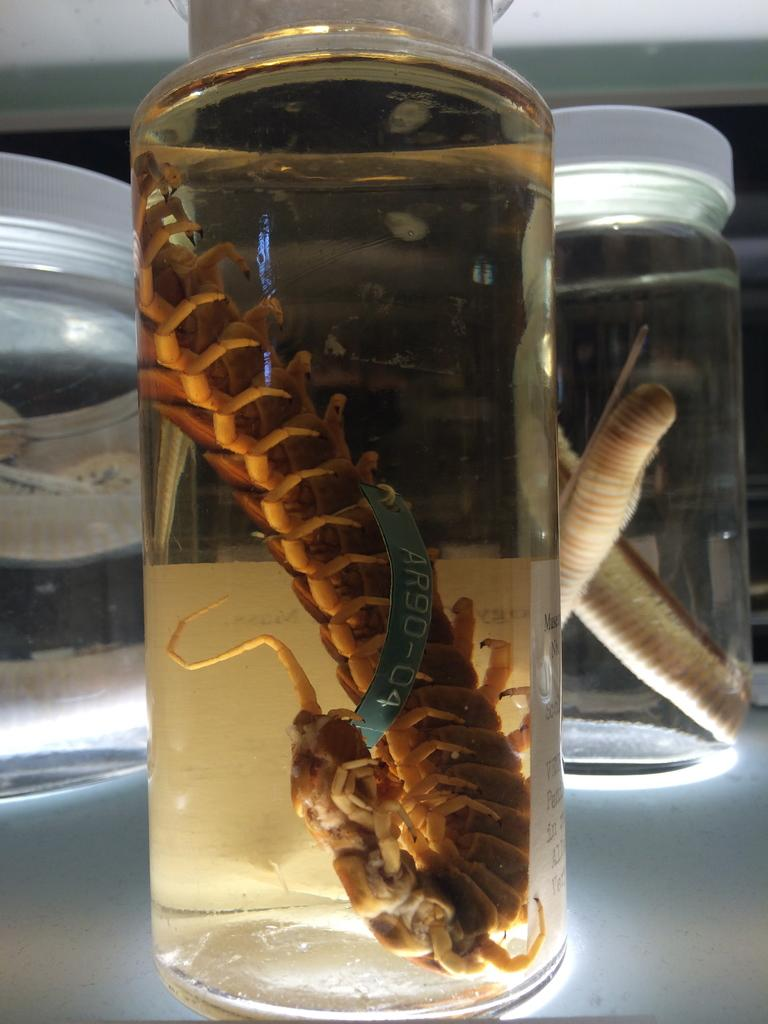How many glass jars are visible in the image? There are three glass jars in the image. What is inside the middle glass jar? One centipede is in the water in the middle glass jar. What is placed on the table behind the glass jars? There is another word placed on the table behind the glass jars. How many kites are flying in the image? There are no kites visible in the image. What type of cars can be seen driving by in the image? There are no cars present in the image. 